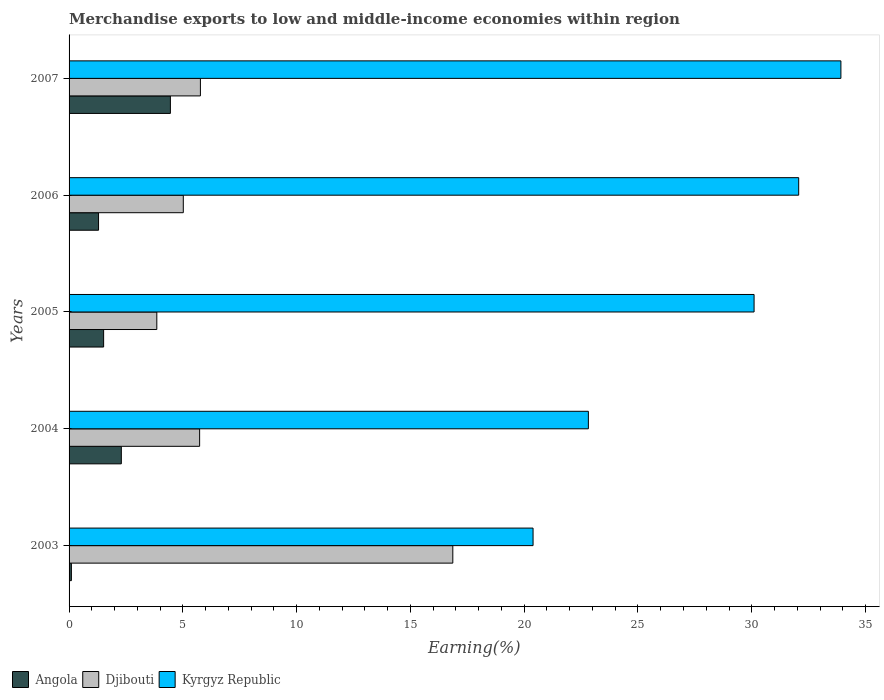Are the number of bars on each tick of the Y-axis equal?
Offer a terse response. Yes. How many bars are there on the 4th tick from the top?
Give a very brief answer. 3. What is the label of the 2nd group of bars from the top?
Ensure brevity in your answer.  2006. What is the percentage of amount earned from merchandise exports in Kyrgyz Republic in 2003?
Offer a very short reply. 20.39. Across all years, what is the maximum percentage of amount earned from merchandise exports in Angola?
Provide a short and direct response. 4.45. Across all years, what is the minimum percentage of amount earned from merchandise exports in Angola?
Make the answer very short. 0.1. In which year was the percentage of amount earned from merchandise exports in Kyrgyz Republic minimum?
Your answer should be compact. 2003. What is the total percentage of amount earned from merchandise exports in Kyrgyz Republic in the graph?
Offer a terse response. 139.29. What is the difference between the percentage of amount earned from merchandise exports in Angola in 2003 and that in 2004?
Offer a very short reply. -2.19. What is the difference between the percentage of amount earned from merchandise exports in Angola in 2004 and the percentage of amount earned from merchandise exports in Djibouti in 2005?
Offer a very short reply. -1.56. What is the average percentage of amount earned from merchandise exports in Kyrgyz Republic per year?
Provide a short and direct response. 27.86. In the year 2004, what is the difference between the percentage of amount earned from merchandise exports in Kyrgyz Republic and percentage of amount earned from merchandise exports in Djibouti?
Your answer should be very brief. 17.08. In how many years, is the percentage of amount earned from merchandise exports in Kyrgyz Republic greater than 4 %?
Your answer should be compact. 5. What is the ratio of the percentage of amount earned from merchandise exports in Kyrgyz Republic in 2006 to that in 2007?
Provide a succinct answer. 0.95. What is the difference between the highest and the second highest percentage of amount earned from merchandise exports in Kyrgyz Republic?
Keep it short and to the point. 1.85. What is the difference between the highest and the lowest percentage of amount earned from merchandise exports in Djibouti?
Provide a succinct answer. 13.01. In how many years, is the percentage of amount earned from merchandise exports in Kyrgyz Republic greater than the average percentage of amount earned from merchandise exports in Kyrgyz Republic taken over all years?
Provide a short and direct response. 3. Is the sum of the percentage of amount earned from merchandise exports in Djibouti in 2004 and 2005 greater than the maximum percentage of amount earned from merchandise exports in Angola across all years?
Your answer should be compact. Yes. What does the 3rd bar from the top in 2006 represents?
Your response must be concise. Angola. What does the 2nd bar from the bottom in 2007 represents?
Keep it short and to the point. Djibouti. How many bars are there?
Your response must be concise. 15. Are all the bars in the graph horizontal?
Ensure brevity in your answer.  Yes. Does the graph contain any zero values?
Offer a very short reply. No. Does the graph contain grids?
Your answer should be very brief. No. Where does the legend appear in the graph?
Offer a very short reply. Bottom left. How many legend labels are there?
Offer a very short reply. 3. How are the legend labels stacked?
Offer a very short reply. Horizontal. What is the title of the graph?
Your answer should be compact. Merchandise exports to low and middle-income economies within region. What is the label or title of the X-axis?
Provide a succinct answer. Earning(%). What is the label or title of the Y-axis?
Your response must be concise. Years. What is the Earning(%) of Angola in 2003?
Provide a succinct answer. 0.1. What is the Earning(%) of Djibouti in 2003?
Your response must be concise. 16.86. What is the Earning(%) of Kyrgyz Republic in 2003?
Your response must be concise. 20.39. What is the Earning(%) in Angola in 2004?
Your response must be concise. 2.3. What is the Earning(%) in Djibouti in 2004?
Provide a succinct answer. 5.74. What is the Earning(%) of Kyrgyz Republic in 2004?
Offer a terse response. 22.82. What is the Earning(%) in Angola in 2005?
Make the answer very short. 1.52. What is the Earning(%) in Djibouti in 2005?
Your response must be concise. 3.86. What is the Earning(%) of Kyrgyz Republic in 2005?
Your answer should be compact. 30.1. What is the Earning(%) of Angola in 2006?
Your answer should be very brief. 1.3. What is the Earning(%) in Djibouti in 2006?
Keep it short and to the point. 5.02. What is the Earning(%) in Kyrgyz Republic in 2006?
Give a very brief answer. 32.06. What is the Earning(%) of Angola in 2007?
Ensure brevity in your answer.  4.45. What is the Earning(%) of Djibouti in 2007?
Offer a very short reply. 5.77. What is the Earning(%) of Kyrgyz Republic in 2007?
Ensure brevity in your answer.  33.92. Across all years, what is the maximum Earning(%) in Angola?
Offer a terse response. 4.45. Across all years, what is the maximum Earning(%) in Djibouti?
Offer a terse response. 16.86. Across all years, what is the maximum Earning(%) of Kyrgyz Republic?
Give a very brief answer. 33.92. Across all years, what is the minimum Earning(%) of Angola?
Ensure brevity in your answer.  0.1. Across all years, what is the minimum Earning(%) in Djibouti?
Offer a terse response. 3.86. Across all years, what is the minimum Earning(%) of Kyrgyz Republic?
Give a very brief answer. 20.39. What is the total Earning(%) in Angola in the graph?
Provide a succinct answer. 9.66. What is the total Earning(%) in Djibouti in the graph?
Offer a terse response. 37.25. What is the total Earning(%) of Kyrgyz Republic in the graph?
Offer a very short reply. 139.29. What is the difference between the Earning(%) of Angola in 2003 and that in 2004?
Your answer should be very brief. -2.19. What is the difference between the Earning(%) of Djibouti in 2003 and that in 2004?
Ensure brevity in your answer.  11.13. What is the difference between the Earning(%) in Kyrgyz Republic in 2003 and that in 2004?
Keep it short and to the point. -2.43. What is the difference between the Earning(%) of Angola in 2003 and that in 2005?
Ensure brevity in your answer.  -1.42. What is the difference between the Earning(%) of Djibouti in 2003 and that in 2005?
Provide a succinct answer. 13.01. What is the difference between the Earning(%) of Kyrgyz Republic in 2003 and that in 2005?
Your answer should be very brief. -9.71. What is the difference between the Earning(%) of Angola in 2003 and that in 2006?
Provide a succinct answer. -1.19. What is the difference between the Earning(%) in Djibouti in 2003 and that in 2006?
Provide a short and direct response. 11.84. What is the difference between the Earning(%) of Kyrgyz Republic in 2003 and that in 2006?
Your answer should be very brief. -11.67. What is the difference between the Earning(%) of Angola in 2003 and that in 2007?
Your response must be concise. -4.35. What is the difference between the Earning(%) in Djibouti in 2003 and that in 2007?
Make the answer very short. 11.09. What is the difference between the Earning(%) in Kyrgyz Republic in 2003 and that in 2007?
Provide a succinct answer. -13.53. What is the difference between the Earning(%) of Angola in 2004 and that in 2005?
Keep it short and to the point. 0.78. What is the difference between the Earning(%) of Djibouti in 2004 and that in 2005?
Offer a very short reply. 1.88. What is the difference between the Earning(%) in Kyrgyz Republic in 2004 and that in 2005?
Your answer should be very brief. -7.28. What is the difference between the Earning(%) of Djibouti in 2004 and that in 2006?
Ensure brevity in your answer.  0.72. What is the difference between the Earning(%) in Kyrgyz Republic in 2004 and that in 2006?
Keep it short and to the point. -9.24. What is the difference between the Earning(%) in Angola in 2004 and that in 2007?
Your response must be concise. -2.16. What is the difference between the Earning(%) of Djibouti in 2004 and that in 2007?
Provide a succinct answer. -0.03. What is the difference between the Earning(%) in Kyrgyz Republic in 2004 and that in 2007?
Provide a succinct answer. -11.1. What is the difference between the Earning(%) in Angola in 2005 and that in 2006?
Give a very brief answer. 0.22. What is the difference between the Earning(%) in Djibouti in 2005 and that in 2006?
Ensure brevity in your answer.  -1.16. What is the difference between the Earning(%) of Kyrgyz Republic in 2005 and that in 2006?
Your response must be concise. -1.96. What is the difference between the Earning(%) in Angola in 2005 and that in 2007?
Your answer should be compact. -2.93. What is the difference between the Earning(%) of Djibouti in 2005 and that in 2007?
Your response must be concise. -1.92. What is the difference between the Earning(%) of Kyrgyz Republic in 2005 and that in 2007?
Give a very brief answer. -3.81. What is the difference between the Earning(%) of Angola in 2006 and that in 2007?
Give a very brief answer. -3.16. What is the difference between the Earning(%) in Djibouti in 2006 and that in 2007?
Provide a succinct answer. -0.75. What is the difference between the Earning(%) of Kyrgyz Republic in 2006 and that in 2007?
Provide a succinct answer. -1.85. What is the difference between the Earning(%) of Angola in 2003 and the Earning(%) of Djibouti in 2004?
Give a very brief answer. -5.64. What is the difference between the Earning(%) of Angola in 2003 and the Earning(%) of Kyrgyz Republic in 2004?
Provide a short and direct response. -22.72. What is the difference between the Earning(%) in Djibouti in 2003 and the Earning(%) in Kyrgyz Republic in 2004?
Provide a succinct answer. -5.96. What is the difference between the Earning(%) of Angola in 2003 and the Earning(%) of Djibouti in 2005?
Keep it short and to the point. -3.75. What is the difference between the Earning(%) of Angola in 2003 and the Earning(%) of Kyrgyz Republic in 2005?
Provide a short and direct response. -30. What is the difference between the Earning(%) in Djibouti in 2003 and the Earning(%) in Kyrgyz Republic in 2005?
Your answer should be very brief. -13.24. What is the difference between the Earning(%) of Angola in 2003 and the Earning(%) of Djibouti in 2006?
Keep it short and to the point. -4.92. What is the difference between the Earning(%) in Angola in 2003 and the Earning(%) in Kyrgyz Republic in 2006?
Ensure brevity in your answer.  -31.96. What is the difference between the Earning(%) of Djibouti in 2003 and the Earning(%) of Kyrgyz Republic in 2006?
Give a very brief answer. -15.2. What is the difference between the Earning(%) of Angola in 2003 and the Earning(%) of Djibouti in 2007?
Offer a very short reply. -5.67. What is the difference between the Earning(%) of Angola in 2003 and the Earning(%) of Kyrgyz Republic in 2007?
Your answer should be very brief. -33.82. What is the difference between the Earning(%) in Djibouti in 2003 and the Earning(%) in Kyrgyz Republic in 2007?
Give a very brief answer. -17.05. What is the difference between the Earning(%) in Angola in 2004 and the Earning(%) in Djibouti in 2005?
Provide a short and direct response. -1.56. What is the difference between the Earning(%) of Angola in 2004 and the Earning(%) of Kyrgyz Republic in 2005?
Keep it short and to the point. -27.81. What is the difference between the Earning(%) of Djibouti in 2004 and the Earning(%) of Kyrgyz Republic in 2005?
Your answer should be compact. -24.37. What is the difference between the Earning(%) of Angola in 2004 and the Earning(%) of Djibouti in 2006?
Your response must be concise. -2.72. What is the difference between the Earning(%) in Angola in 2004 and the Earning(%) in Kyrgyz Republic in 2006?
Give a very brief answer. -29.77. What is the difference between the Earning(%) of Djibouti in 2004 and the Earning(%) of Kyrgyz Republic in 2006?
Provide a short and direct response. -26.33. What is the difference between the Earning(%) of Angola in 2004 and the Earning(%) of Djibouti in 2007?
Give a very brief answer. -3.47. What is the difference between the Earning(%) in Angola in 2004 and the Earning(%) in Kyrgyz Republic in 2007?
Keep it short and to the point. -31.62. What is the difference between the Earning(%) in Djibouti in 2004 and the Earning(%) in Kyrgyz Republic in 2007?
Your response must be concise. -28.18. What is the difference between the Earning(%) of Angola in 2005 and the Earning(%) of Djibouti in 2006?
Offer a very short reply. -3.5. What is the difference between the Earning(%) of Angola in 2005 and the Earning(%) of Kyrgyz Republic in 2006?
Offer a terse response. -30.54. What is the difference between the Earning(%) of Djibouti in 2005 and the Earning(%) of Kyrgyz Republic in 2006?
Keep it short and to the point. -28.21. What is the difference between the Earning(%) of Angola in 2005 and the Earning(%) of Djibouti in 2007?
Provide a succinct answer. -4.25. What is the difference between the Earning(%) of Angola in 2005 and the Earning(%) of Kyrgyz Republic in 2007?
Give a very brief answer. -32.4. What is the difference between the Earning(%) in Djibouti in 2005 and the Earning(%) in Kyrgyz Republic in 2007?
Provide a succinct answer. -30.06. What is the difference between the Earning(%) of Angola in 2006 and the Earning(%) of Djibouti in 2007?
Give a very brief answer. -4.48. What is the difference between the Earning(%) in Angola in 2006 and the Earning(%) in Kyrgyz Republic in 2007?
Give a very brief answer. -32.62. What is the difference between the Earning(%) in Djibouti in 2006 and the Earning(%) in Kyrgyz Republic in 2007?
Keep it short and to the point. -28.9. What is the average Earning(%) in Angola per year?
Keep it short and to the point. 1.93. What is the average Earning(%) in Djibouti per year?
Ensure brevity in your answer.  7.45. What is the average Earning(%) of Kyrgyz Republic per year?
Your answer should be compact. 27.86. In the year 2003, what is the difference between the Earning(%) of Angola and Earning(%) of Djibouti?
Your answer should be very brief. -16.76. In the year 2003, what is the difference between the Earning(%) of Angola and Earning(%) of Kyrgyz Republic?
Keep it short and to the point. -20.29. In the year 2003, what is the difference between the Earning(%) of Djibouti and Earning(%) of Kyrgyz Republic?
Your answer should be compact. -3.53. In the year 2004, what is the difference between the Earning(%) of Angola and Earning(%) of Djibouti?
Your response must be concise. -3.44. In the year 2004, what is the difference between the Earning(%) in Angola and Earning(%) in Kyrgyz Republic?
Your answer should be compact. -20.52. In the year 2004, what is the difference between the Earning(%) of Djibouti and Earning(%) of Kyrgyz Republic?
Your answer should be compact. -17.08. In the year 2005, what is the difference between the Earning(%) of Angola and Earning(%) of Djibouti?
Provide a succinct answer. -2.34. In the year 2005, what is the difference between the Earning(%) in Angola and Earning(%) in Kyrgyz Republic?
Make the answer very short. -28.58. In the year 2005, what is the difference between the Earning(%) of Djibouti and Earning(%) of Kyrgyz Republic?
Give a very brief answer. -26.25. In the year 2006, what is the difference between the Earning(%) in Angola and Earning(%) in Djibouti?
Provide a short and direct response. -3.72. In the year 2006, what is the difference between the Earning(%) of Angola and Earning(%) of Kyrgyz Republic?
Your answer should be very brief. -30.77. In the year 2006, what is the difference between the Earning(%) of Djibouti and Earning(%) of Kyrgyz Republic?
Your response must be concise. -27.04. In the year 2007, what is the difference between the Earning(%) of Angola and Earning(%) of Djibouti?
Make the answer very short. -1.32. In the year 2007, what is the difference between the Earning(%) of Angola and Earning(%) of Kyrgyz Republic?
Provide a short and direct response. -29.46. In the year 2007, what is the difference between the Earning(%) of Djibouti and Earning(%) of Kyrgyz Republic?
Offer a terse response. -28.15. What is the ratio of the Earning(%) of Angola in 2003 to that in 2004?
Give a very brief answer. 0.04. What is the ratio of the Earning(%) in Djibouti in 2003 to that in 2004?
Your answer should be very brief. 2.94. What is the ratio of the Earning(%) in Kyrgyz Republic in 2003 to that in 2004?
Keep it short and to the point. 0.89. What is the ratio of the Earning(%) of Angola in 2003 to that in 2005?
Your answer should be compact. 0.07. What is the ratio of the Earning(%) in Djibouti in 2003 to that in 2005?
Keep it short and to the point. 4.37. What is the ratio of the Earning(%) of Kyrgyz Republic in 2003 to that in 2005?
Give a very brief answer. 0.68. What is the ratio of the Earning(%) of Angola in 2003 to that in 2006?
Provide a succinct answer. 0.08. What is the ratio of the Earning(%) in Djibouti in 2003 to that in 2006?
Your response must be concise. 3.36. What is the ratio of the Earning(%) of Kyrgyz Republic in 2003 to that in 2006?
Make the answer very short. 0.64. What is the ratio of the Earning(%) in Angola in 2003 to that in 2007?
Provide a short and direct response. 0.02. What is the ratio of the Earning(%) of Djibouti in 2003 to that in 2007?
Give a very brief answer. 2.92. What is the ratio of the Earning(%) of Kyrgyz Republic in 2003 to that in 2007?
Your answer should be compact. 0.6. What is the ratio of the Earning(%) in Angola in 2004 to that in 2005?
Make the answer very short. 1.51. What is the ratio of the Earning(%) of Djibouti in 2004 to that in 2005?
Offer a very short reply. 1.49. What is the ratio of the Earning(%) in Kyrgyz Republic in 2004 to that in 2005?
Provide a succinct answer. 0.76. What is the ratio of the Earning(%) of Angola in 2004 to that in 2006?
Your answer should be very brief. 1.77. What is the ratio of the Earning(%) in Djibouti in 2004 to that in 2006?
Make the answer very short. 1.14. What is the ratio of the Earning(%) of Kyrgyz Republic in 2004 to that in 2006?
Give a very brief answer. 0.71. What is the ratio of the Earning(%) in Angola in 2004 to that in 2007?
Provide a succinct answer. 0.52. What is the ratio of the Earning(%) of Kyrgyz Republic in 2004 to that in 2007?
Provide a short and direct response. 0.67. What is the ratio of the Earning(%) in Angola in 2005 to that in 2006?
Your response must be concise. 1.17. What is the ratio of the Earning(%) of Djibouti in 2005 to that in 2006?
Provide a short and direct response. 0.77. What is the ratio of the Earning(%) in Kyrgyz Republic in 2005 to that in 2006?
Your answer should be compact. 0.94. What is the ratio of the Earning(%) in Angola in 2005 to that in 2007?
Give a very brief answer. 0.34. What is the ratio of the Earning(%) in Djibouti in 2005 to that in 2007?
Your response must be concise. 0.67. What is the ratio of the Earning(%) in Kyrgyz Republic in 2005 to that in 2007?
Your response must be concise. 0.89. What is the ratio of the Earning(%) in Angola in 2006 to that in 2007?
Provide a short and direct response. 0.29. What is the ratio of the Earning(%) in Djibouti in 2006 to that in 2007?
Provide a short and direct response. 0.87. What is the ratio of the Earning(%) of Kyrgyz Republic in 2006 to that in 2007?
Offer a very short reply. 0.95. What is the difference between the highest and the second highest Earning(%) of Angola?
Offer a terse response. 2.16. What is the difference between the highest and the second highest Earning(%) of Djibouti?
Offer a very short reply. 11.09. What is the difference between the highest and the second highest Earning(%) in Kyrgyz Republic?
Offer a terse response. 1.85. What is the difference between the highest and the lowest Earning(%) in Angola?
Provide a short and direct response. 4.35. What is the difference between the highest and the lowest Earning(%) of Djibouti?
Your response must be concise. 13.01. What is the difference between the highest and the lowest Earning(%) in Kyrgyz Republic?
Your response must be concise. 13.53. 